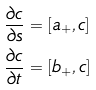<formula> <loc_0><loc_0><loc_500><loc_500>\frac { \partial c } { \partial s } & = [ a _ { + } , c ] \\ \frac { \partial c } { \partial t } & = [ b _ { + } , c ] \\</formula> 